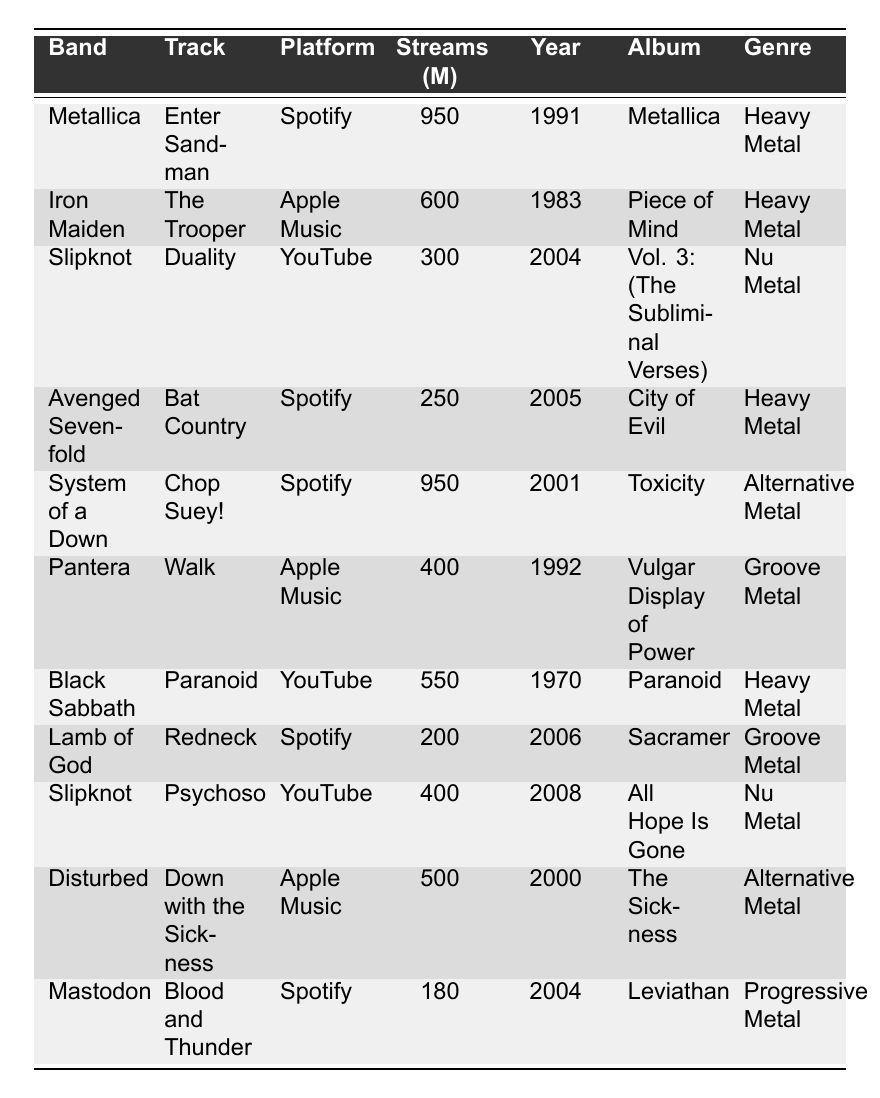What is the track with the highest number of streams? The highest number of streams listed in the table is 950 million for "Enter Sandman" by Metallica.
Answer: Enter Sandman Which band has the most streams on Spotify? In the table, Metallica's "Enter Sandman" has 950 million streams on Spotify, which is the highest compared to other bands listed.
Answer: Metallica How many streams does "Paranoid" by Black Sabbath have? The table shows that "Paranoid" by Black Sabbath has 550 million streams.
Answer: 550 million Which band released a track in the year 2000? The table lists "Down with the Sickness" by Disturbed with a release year of 2000.
Answer: Disturbed What is the total number of streams for Slipknot's tracks listed? Slipknot's tracks, "Duality" (300 million) and "Psychosocial" (400 million), add up to 700 million streams in total.
Answer: 700 million Is "Chop Suey!" by System of a Down considered Heavy Metal? According to the table, "Chop Suey!" is classified as Alternative Metal, not Heavy Metal.
Answer: No Which platform has the least total streams based on the table? Analyzing the streams, YouTube has a total of 700 million (300 million for "Duality" and 400 million for "Psychosocial"), which is lower than the totals for Spotify and Apple Music.
Answer: YouTube How many different genres are represented in the table? The table shows 5 distinct genres: Heavy Metal, Nu Metal, Alternative Metal, Groove Metal, and Progressive Metal.
Answer: 5 What is the average number of streams for tracks listed on Apple Music? The total streams for Apple Music tracks are 600 million ("The Trooper" by Iron Maiden) + 400 million ("Walk" by Pantera) + 500 million ("Down with the Sickness" by Disturbed) = 1500 million, and there are 3 tracks, so the average is 1500 million / 3 = 500 million.
Answer: 500 million Which band from the table has the latest release year? The latest release year listed is 2008 for "Psychosocial" by Slipknot.
Answer: Slipknot How many heavy metal tracks are listed in total? The heavy metal tracks listed in the table are "Enter Sandman," "The Trooper," "Bat Country," "Paranoid," so there are 4 heavy metal tracks in total.
Answer: 4 What is the difference in streams between the most and least streamed track? The most streamed track is "Enter Sandman" with 950 million streams, and the least streamed track is "Blood and Thunder" with 180 million streams. The difference is 950 million - 180 million = 770 million.
Answer: 770 million 